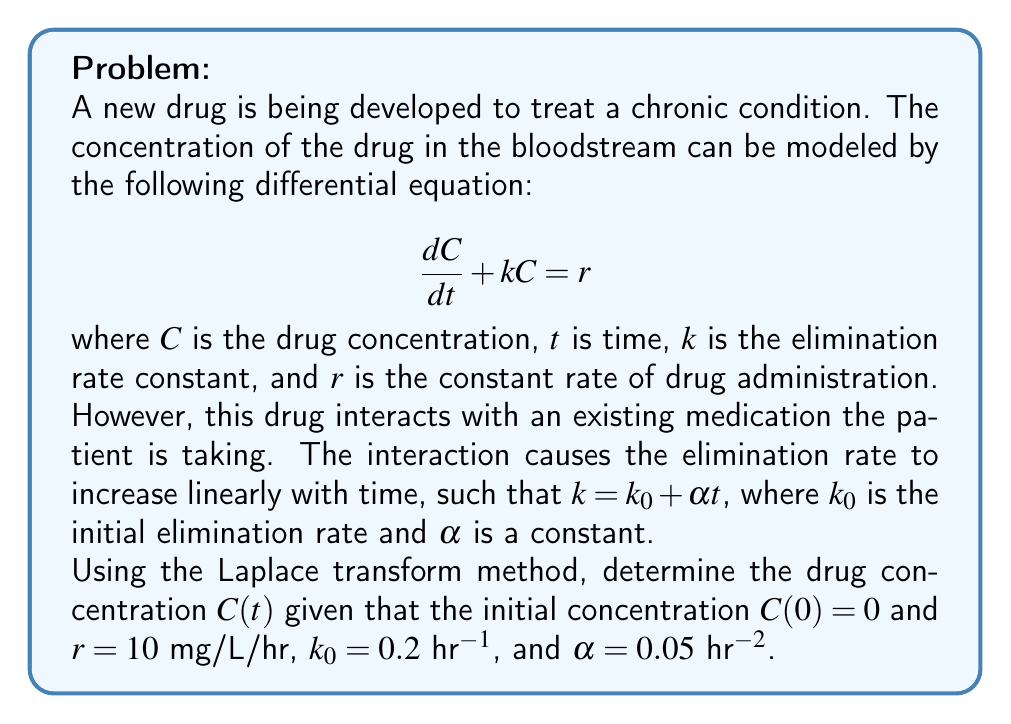Teach me how to tackle this problem. Let's solve this step-by-step using the Laplace transform method:

1) The modified differential equation is:

   $$\frac{dC}{dt} + (k_0 + \alpha t)C = r$$

2) Take the Laplace transform of both sides. Let $\mathcal{L}\{C(t)\} = \bar{C}(s)$:

   $$\mathcal{L}\{\frac{dC}{dt}\} + \mathcal{L}\{(k_0 + \alpha t)C\} = \mathcal{L}\{r\}$$

3) Using Laplace transform properties:

   $$s\bar{C}(s) - C(0) + k_0\bar{C}(s) + \alpha\frac{d}{ds}\bar{C}(s) = \frac{r}{s}$$

4) Given $C(0) = 0$ and substituting the values:

   $$s\bar{C}(s) + 0.2\bar{C}(s) + 0.05\frac{d}{ds}\bar{C}(s) = \frac{10}{s}$$

5) Rearrange:

   $$0.05\frac{d}{ds}\bar{C}(s) + (s + 0.2)\bar{C}(s) = \frac{10}{s}$$

6) This is a first-order linear differential equation in $\bar{C}(s)$. The integrating factor is:

   $$\mu(s) = e^{\int \frac{s+0.2}{0.05}ds} = e^{10s + 4s^2}$$

7) Multiply both sides by $\mu(s)$:

   $$\frac{d}{ds}(\mu(s)\bar{C}(s)) = \frac{10}{s}e^{10s + 4s^2}$$

8) Integrate both sides:

   $$\mu(s)\bar{C}(s) = 10\int \frac{1}{s}e^{10s + 4s^2}ds$$

9) The integral on the right-hand side doesn't have a closed-form solution. Let's call it $I(s)$. Then:

   $$\bar{C}(s) = 10e^{-10s - 4s^2}I(s)$$

10) To find $C(t)$, we need to take the inverse Laplace transform:

    $$C(t) = 10\mathcal{L}^{-1}\{e^{-10s - 4s^2}I(s)\}$$

11) This inverse Laplace transform doesn't have a simple closed-form solution and would typically be evaluated numerically or approximated.
Answer: $C(t) = 10\mathcal{L}^{-1}\{e^{-10s - 4s^2}I(s)\}$, where $I(s) = \int \frac{1}{s}e^{10s + 4s^2}ds$ 